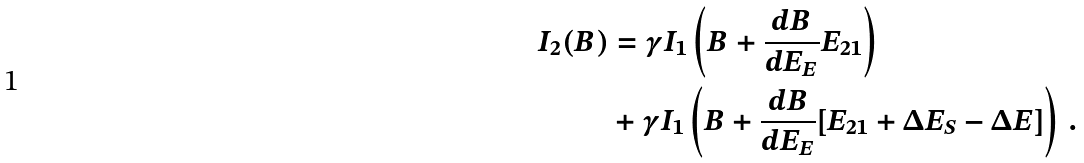Convert formula to latex. <formula><loc_0><loc_0><loc_500><loc_500>I _ { 2 } ( B ) & = \gamma I _ { 1 } \left ( B + \frac { d B } { d E _ { E } } E _ { 2 1 } \right ) \\ & + \gamma I _ { 1 } \left ( B + \frac { d B } { d E _ { E } } [ E _ { 2 1 } + \Delta E _ { S } - \Delta E ] \right ) \, . \\</formula> 